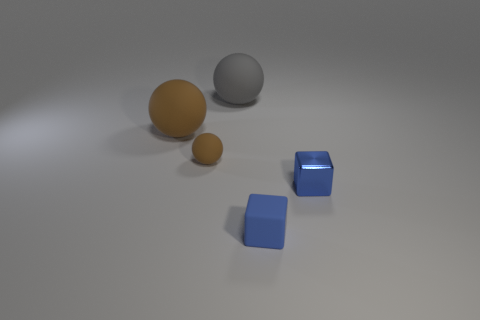Is there any other thing that is the same material as the small brown thing?
Your response must be concise. Yes. There is a small blue thing in front of the tiny blue metal thing; what is its material?
Your answer should be compact. Rubber. Does the rubber block have the same size as the metallic object?
Provide a short and direct response. Yes. How many other objects are there of the same size as the blue shiny object?
Make the answer very short. 2. Is the small ball the same color as the matte cube?
Give a very brief answer. No. What is the shape of the brown matte thing right of the thing that is on the left side of the small thing that is to the left of the large gray object?
Make the answer very short. Sphere. How many objects are either brown matte objects behind the tiny matte ball or large spheres left of the large gray object?
Your answer should be compact. 1. There is a blue block behind the small matte block in front of the small metallic thing; what is its size?
Your response must be concise. Small. There is a tiny cube behind the blue rubber cube; does it have the same color as the tiny matte ball?
Your answer should be compact. No. Is there another brown rubber object that has the same shape as the big brown object?
Your answer should be very brief. Yes. 